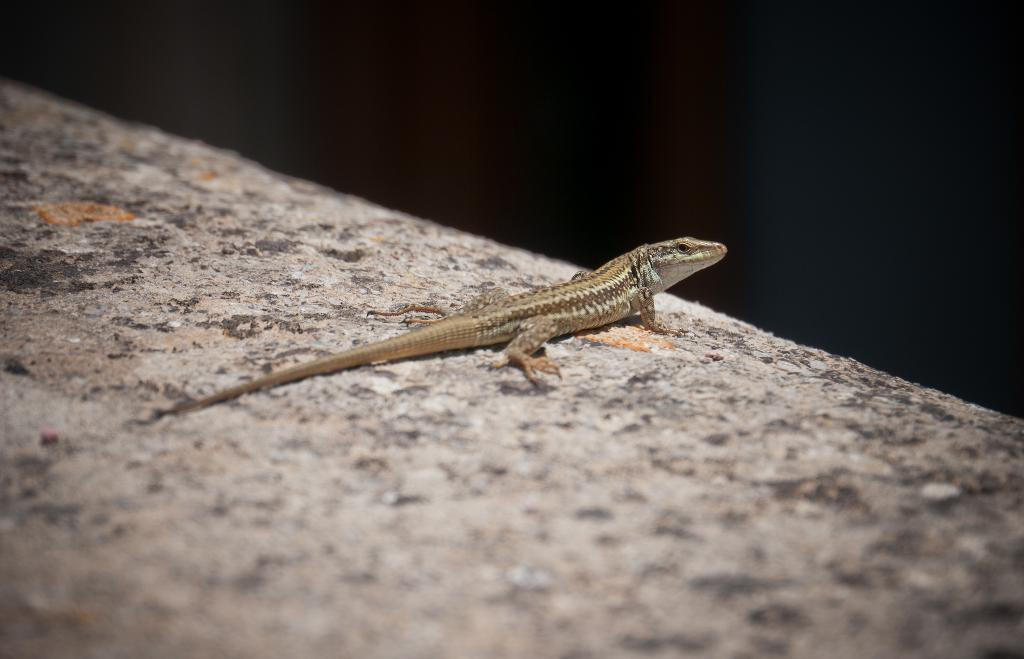What type of animal is in the image? There is a lizard in the image. What color is the lizard? The lizard is brown in color. What surface is the lizard lying on? The lizard is lying on a stone. What type of clouds can be seen in the image? There are no clouds present in the image, as it features a lizard lying on a stone. 